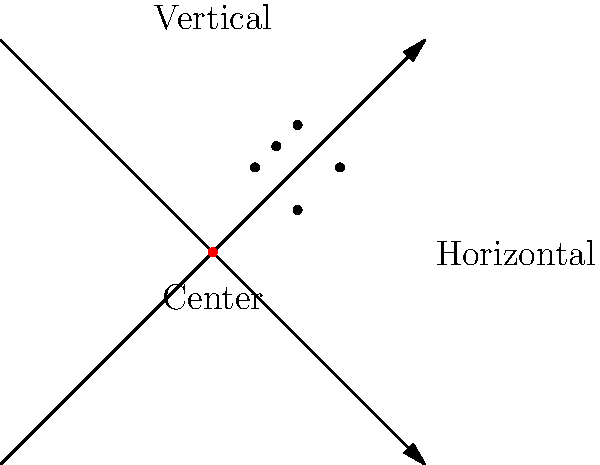You've just fired a group of 5 shots at a target 100 yards away. The diagram shows the grouping of your shots relative to the center of the target. Each grid square represents 1 inch. What sight adjustments (in MOA) do you need to make to center your group on the target? To determine the necessary sight adjustments, we need to follow these steps:

1. Calculate the center of the shot group:
   Horizontal average: $(1 + 2 + 3 + 2 + 1.5) / 5 = 1.9$ inches right
   Vertical average: $(2 + 1 + 2 + 3 + 2.5) / 5 = 2.1$ inches high

2. Convert inches to Minutes of Angle (MOA):
   At 100 yards, 1 MOA ≈ 1.047 inches
   
   Horizontal: $1.9 \text{ inches} / 1.047 \text{ inches/MOA} \approx 1.81 \text{ MOA}$
   Vertical: $2.1 \text{ inches} / 1.047 \text{ inches/MOA} \approx 2.01 \text{ MOA}$

3. Determine adjustment direction:
   To center the group, we need to move the point of impact left and down.

4. Round to the nearest 1/4 MOA for practical adjustment:
   Horizontal: 1.81 MOA ≈ 1.75 MOA left
   Vertical: 2.01 MOA ≈ 2 MOA down

Therefore, the sight adjustments needed are 1.75 MOA left and 2 MOA down.
Answer: 1.75 MOA left, 2 MOA down 